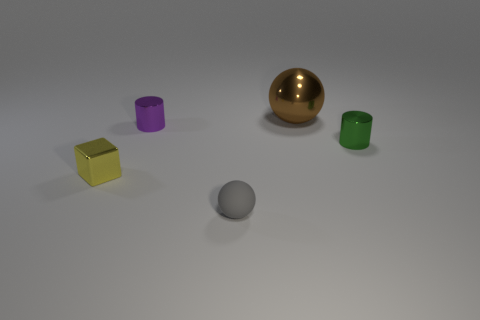What number of things are on the left side of the small green metallic object and in front of the brown shiny sphere?
Your answer should be very brief. 3. Is there anything else that has the same size as the rubber ball?
Your answer should be compact. Yes. Is the number of small balls that are to the right of the tiny green cylinder greater than the number of small green metal cylinders that are behind the large object?
Provide a succinct answer. No. What material is the sphere in front of the green object?
Keep it short and to the point. Rubber. There is a purple shiny thing; is it the same shape as the small metallic thing to the right of the brown shiny object?
Your answer should be very brief. Yes. There is a small shiny cylinder that is to the right of the ball in front of the yellow shiny object; what number of metal cylinders are to the left of it?
Your answer should be very brief. 1. What is the color of the other thing that is the same shape as the small gray matte object?
Provide a short and direct response. Brown. Are there any other things that have the same shape as the brown object?
Your answer should be very brief. Yes. How many balls are purple objects or big brown objects?
Keep it short and to the point. 1. There is a small yellow object; what shape is it?
Give a very brief answer. Cube. 